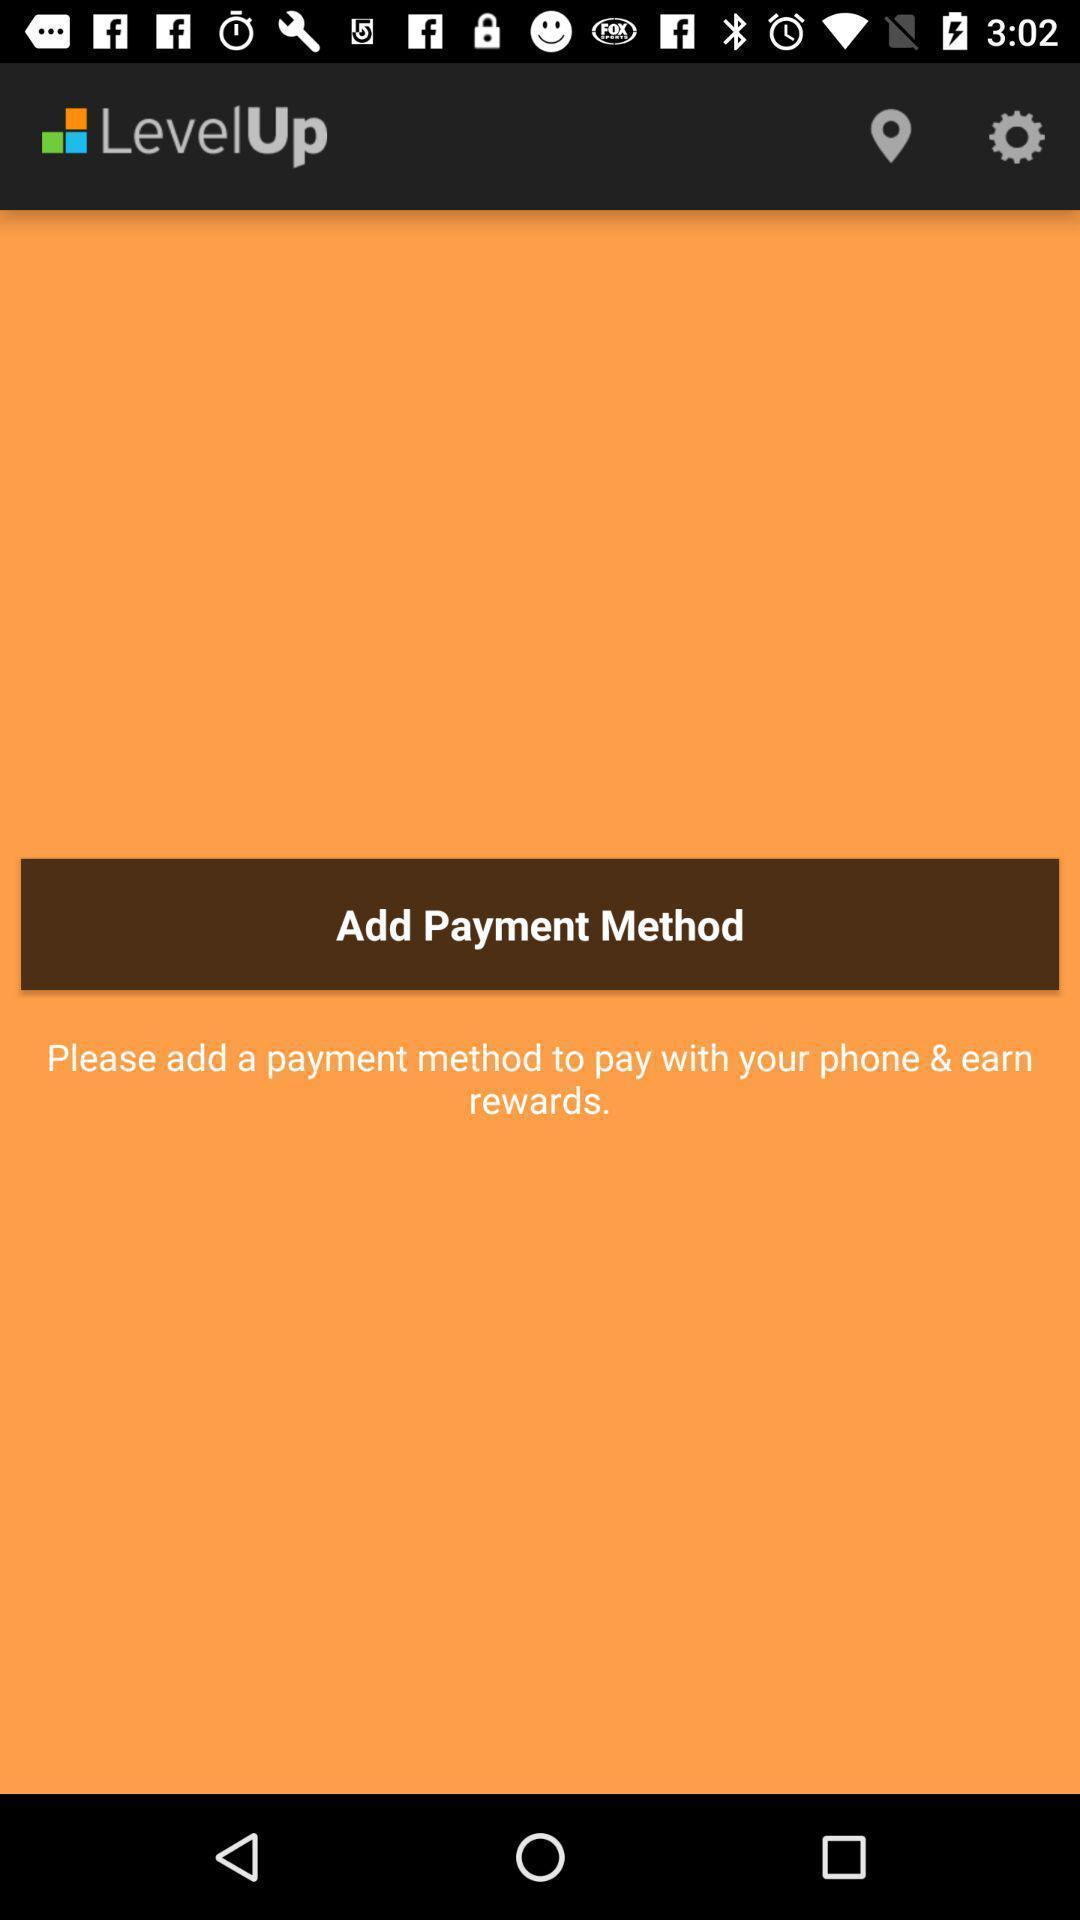Provide a description of this screenshot. Payment page for financial app. 